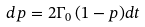Convert formula to latex. <formula><loc_0><loc_0><loc_500><loc_500>d p = 2 \Gamma _ { 0 } \, ( 1 - p ) d t</formula> 